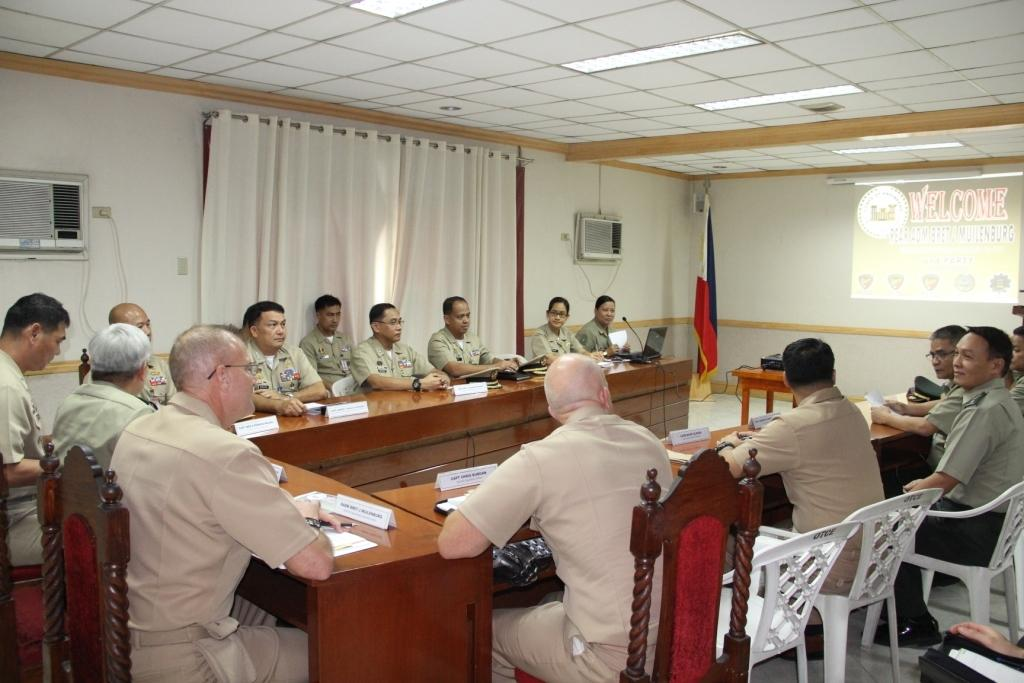What type of people are in the image? There is a group of army officers in the image. What are the army officers doing in the image? The army officers are sitting around a table and discussing. Are there any women in the group? Yes, there are women in the group. What is present in front of the group? There is a screen in the front of the group. What type of care can be seen being provided to the worm in the image? There is no worm present in the image, so no care can be observed. 